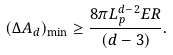<formula> <loc_0><loc_0><loc_500><loc_500>( \Delta A _ { d } ) _ { \min } \geq \frac { 8 \pi L _ { p } ^ { d - 2 } E R } { ( d - 3 ) } .</formula> 